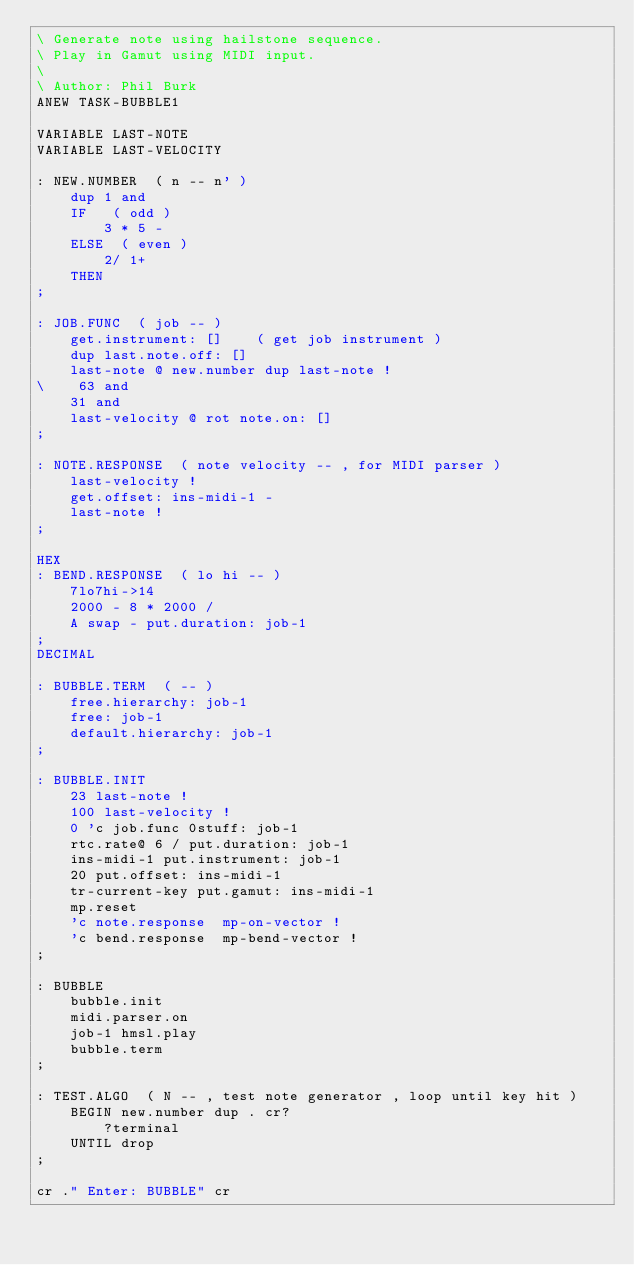<code> <loc_0><loc_0><loc_500><loc_500><_Forth_>\ Generate note using hailstone sequence.
\ Play in Gamut using MIDI input.
\
\ Author: Phil Burk
ANEW TASK-BUBBLE1

VARIABLE LAST-NOTE
VARIABLE LAST-VELOCITY

: NEW.NUMBER  ( n -- n' )
    dup 1 and
    IF   ( odd )
        3 * 5 -
    ELSE  ( even )
        2/ 1+
    THEN
;

: JOB.FUNC  ( job -- )
    get.instrument: []    ( get job instrument )
    dup last.note.off: []
    last-note @ new.number dup last-note !
\    63 and
    31 and
    last-velocity @ rot note.on: []
;

: NOTE.RESPONSE  ( note velocity -- , for MIDI parser )
    last-velocity !
    get.offset: ins-midi-1 -
    last-note !
;

HEX
: BEND.RESPONSE  ( lo hi -- )
    7lo7hi->14
    2000 - 8 * 2000 /
    A swap - put.duration: job-1
;
DECIMAL

: BUBBLE.TERM  ( -- )
    free.hierarchy: job-1
    free: job-1
    default.hierarchy: job-1
;

: BUBBLE.INIT
    23 last-note !
    100 last-velocity !
    0 'c job.func 0stuff: job-1
    rtc.rate@ 6 / put.duration: job-1
    ins-midi-1 put.instrument: job-1
    20 put.offset: ins-midi-1
    tr-current-key put.gamut: ins-midi-1
    mp.reset
    'c note.response  mp-on-vector !
    'c bend.response  mp-bend-vector !
;

: BUBBLE
    bubble.init
    midi.parser.on
    job-1 hmsl.play
    bubble.term
;

: TEST.ALGO  ( N -- , test note generator , loop until key hit )
    BEGIN new.number dup . cr?
        ?terminal
    UNTIL drop
;

cr ." Enter: BUBBLE" cr

</code> 